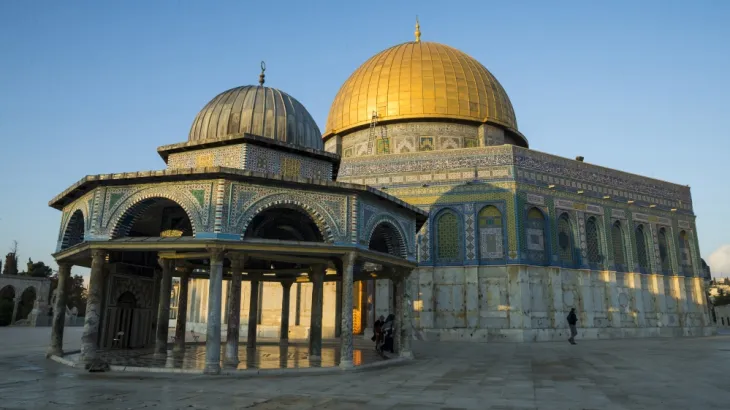What architectural styles can be seen in the mosque's design? The architecture of the Al Aqsa Mosque is a fascinating amalgamation of various styles accumulated over centuries. The most prominent feature is its expansive use of Byzantine design, visible in the detailed mosaics and the overarching style of the domes. Overlaid on this are distinct Islamic architectural elements like pointed arches, arabesque designs, and Islamic calligraphy. Additionally, the structure incorporates elements from the Crusader period, as well as renovations from the Ottoman era, showcasing a rich tapestry of historical influences. 